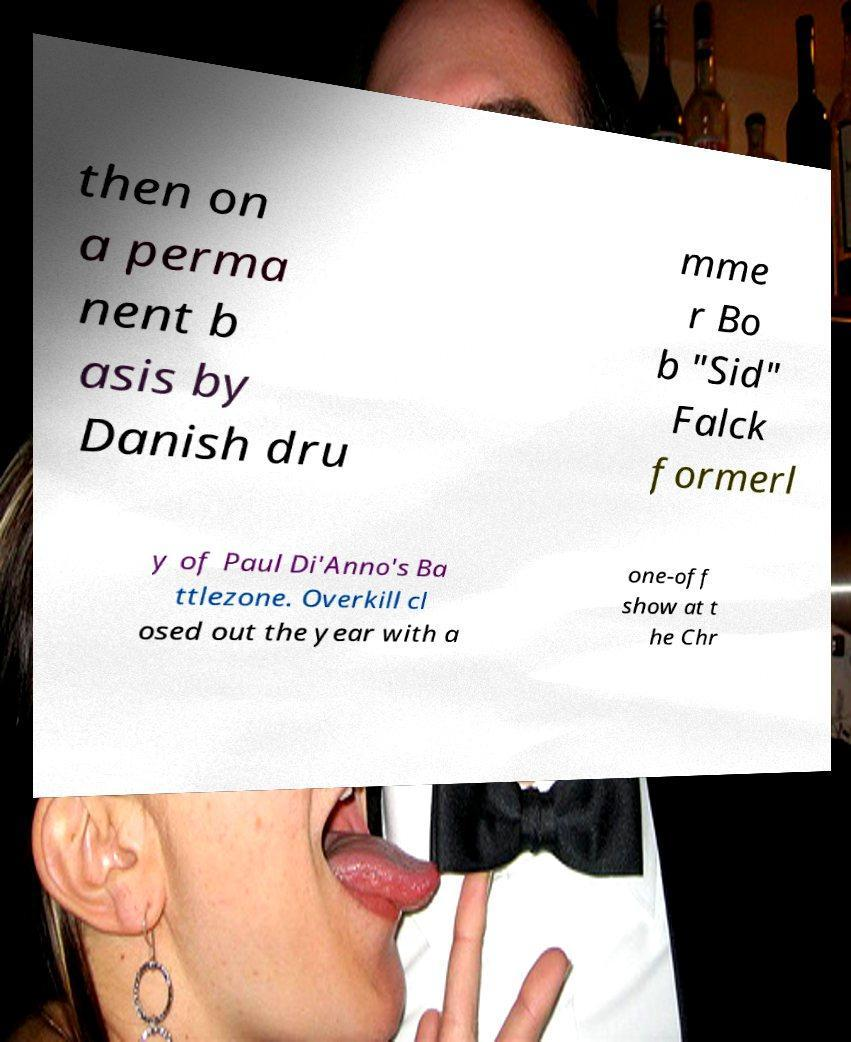There's text embedded in this image that I need extracted. Can you transcribe it verbatim? then on a perma nent b asis by Danish dru mme r Bo b "Sid" Falck formerl y of Paul Di'Anno's Ba ttlezone. Overkill cl osed out the year with a one-off show at t he Chr 